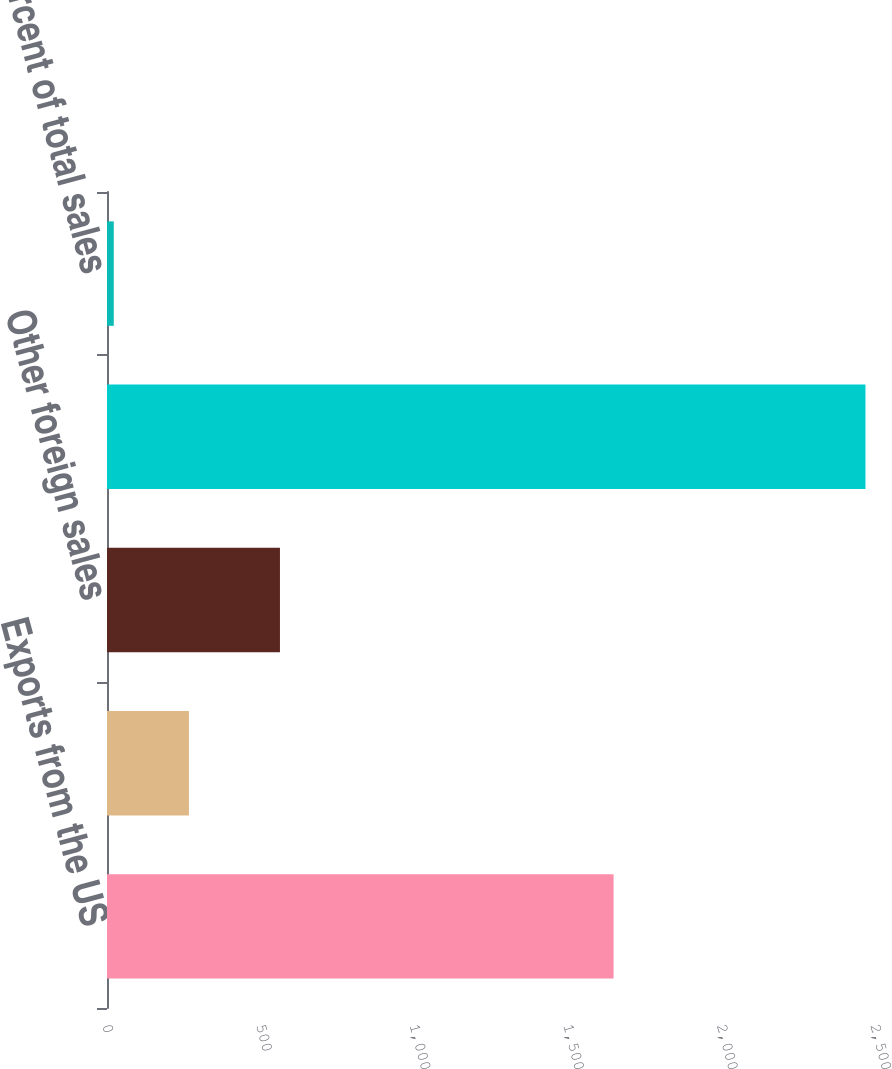Convert chart. <chart><loc_0><loc_0><loc_500><loc_500><bar_chart><fcel>Exports from the US<fcel>Canadian export and domestic<fcel>Other foreign sales<fcel>Total<fcel>Percent of total sales<nl><fcel>1649<fcel>266.7<fcel>563<fcel>2469<fcel>22<nl></chart> 